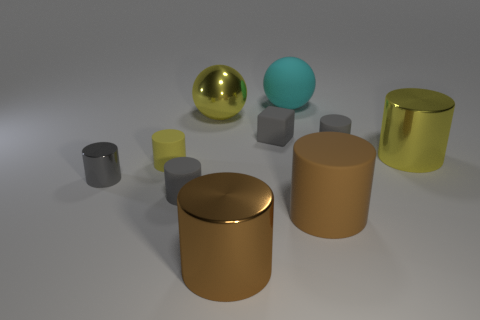There is a object that is behind the block and to the left of the gray cube; what is its size?
Offer a very short reply. Large. How many other things are the same shape as the brown metal object?
Make the answer very short. 6. What number of other objects are the same material as the cyan object?
Give a very brief answer. 5. What size is the gray metallic thing that is the same shape as the tiny yellow matte thing?
Your response must be concise. Small. Is the big rubber cylinder the same color as the small metal thing?
Keep it short and to the point. No. What color is the rubber cylinder that is on the right side of the cyan thing and in front of the gray metallic thing?
Provide a short and direct response. Brown. What number of objects are either gray rubber things right of the cyan thing or cyan matte balls?
Offer a terse response. 2. There is another large matte object that is the same shape as the yellow rubber object; what color is it?
Provide a succinct answer. Brown. Does the brown metallic thing have the same shape as the large cyan rubber object behind the large brown rubber object?
Your response must be concise. No. How many things are either small matte things in front of the small metal object or yellow objects that are left of the big cyan sphere?
Provide a short and direct response. 3. 